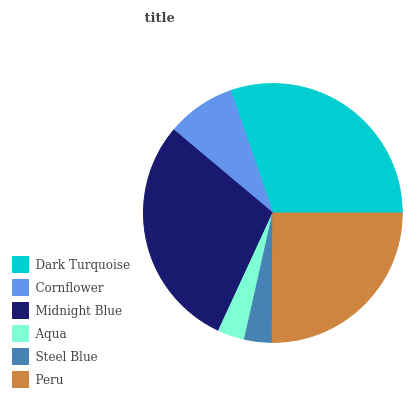Is Aqua the minimum?
Answer yes or no. Yes. Is Dark Turquoise the maximum?
Answer yes or no. Yes. Is Cornflower the minimum?
Answer yes or no. No. Is Cornflower the maximum?
Answer yes or no. No. Is Dark Turquoise greater than Cornflower?
Answer yes or no. Yes. Is Cornflower less than Dark Turquoise?
Answer yes or no. Yes. Is Cornflower greater than Dark Turquoise?
Answer yes or no. No. Is Dark Turquoise less than Cornflower?
Answer yes or no. No. Is Peru the high median?
Answer yes or no. Yes. Is Cornflower the low median?
Answer yes or no. Yes. Is Midnight Blue the high median?
Answer yes or no. No. Is Midnight Blue the low median?
Answer yes or no. No. 